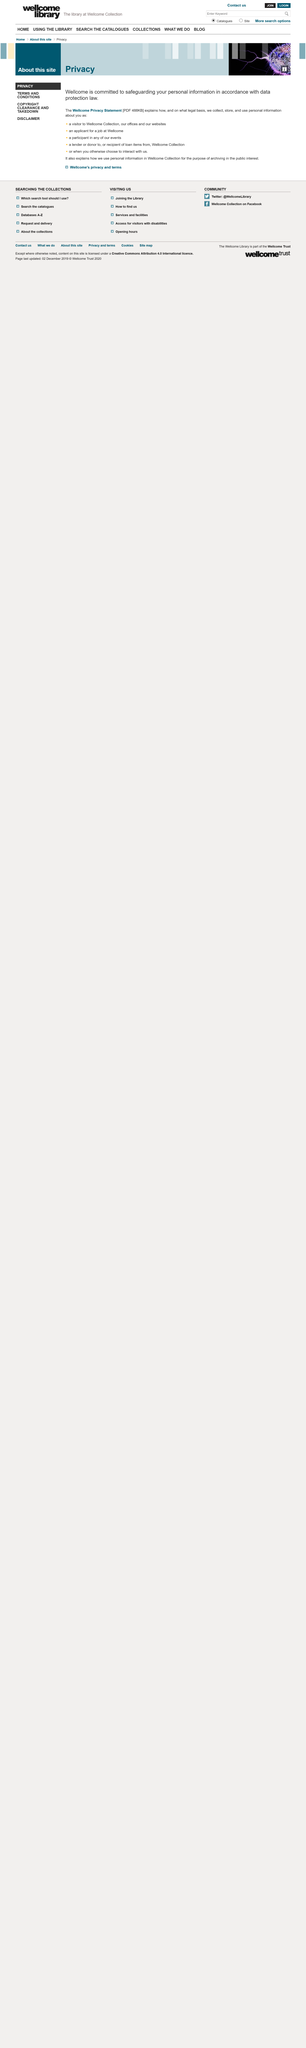Mention a couple of crucial points in this snapshot. Wellcome protects your information and is committed to safeguarding it in accordance with data protection law. The Wellcome Privacy Statement is 488KB in size. The Wellcome Privacy Statement explains the collection, storage, and use of personal information about individuals on what legal basis. 